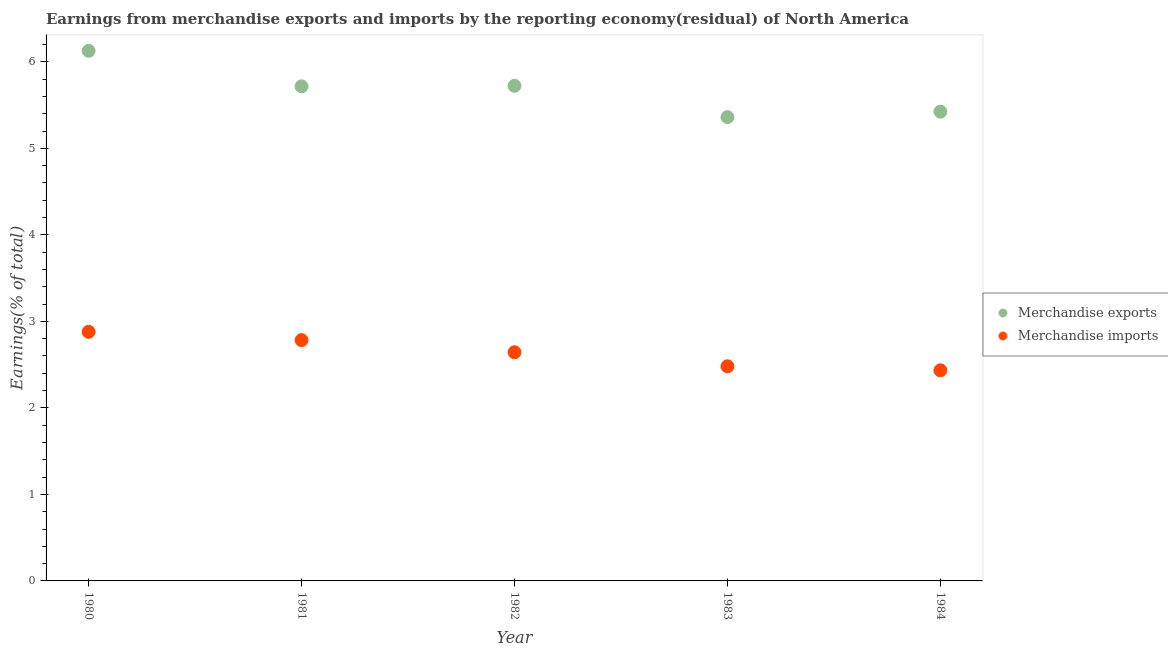Is the number of dotlines equal to the number of legend labels?
Your answer should be compact. Yes. What is the earnings from merchandise exports in 1983?
Make the answer very short. 5.36. Across all years, what is the maximum earnings from merchandise imports?
Provide a succinct answer. 2.88. Across all years, what is the minimum earnings from merchandise imports?
Offer a very short reply. 2.43. What is the total earnings from merchandise exports in the graph?
Make the answer very short. 28.35. What is the difference between the earnings from merchandise exports in 1980 and that in 1983?
Provide a succinct answer. 0.77. What is the difference between the earnings from merchandise exports in 1981 and the earnings from merchandise imports in 1980?
Make the answer very short. 2.84. What is the average earnings from merchandise imports per year?
Your answer should be very brief. 2.64. In the year 1984, what is the difference between the earnings from merchandise exports and earnings from merchandise imports?
Your answer should be very brief. 2.99. In how many years, is the earnings from merchandise imports greater than 2 %?
Offer a very short reply. 5. What is the ratio of the earnings from merchandise imports in 1981 to that in 1982?
Offer a very short reply. 1.05. Is the earnings from merchandise exports in 1981 less than that in 1983?
Keep it short and to the point. No. Is the difference between the earnings from merchandise imports in 1980 and 1981 greater than the difference between the earnings from merchandise exports in 1980 and 1981?
Keep it short and to the point. No. What is the difference between the highest and the second highest earnings from merchandise imports?
Ensure brevity in your answer.  0.1. What is the difference between the highest and the lowest earnings from merchandise exports?
Keep it short and to the point. 0.77. In how many years, is the earnings from merchandise imports greater than the average earnings from merchandise imports taken over all years?
Make the answer very short. 2. Is the sum of the earnings from merchandise imports in 1981 and 1983 greater than the maximum earnings from merchandise exports across all years?
Keep it short and to the point. No. Does the earnings from merchandise exports monotonically increase over the years?
Ensure brevity in your answer.  No. Is the earnings from merchandise imports strictly greater than the earnings from merchandise exports over the years?
Your answer should be compact. No. Is the earnings from merchandise imports strictly less than the earnings from merchandise exports over the years?
Provide a short and direct response. Yes. How many dotlines are there?
Your answer should be very brief. 2. How many years are there in the graph?
Your answer should be compact. 5. What is the difference between two consecutive major ticks on the Y-axis?
Your response must be concise. 1. Does the graph contain any zero values?
Keep it short and to the point. No. Where does the legend appear in the graph?
Make the answer very short. Center right. How many legend labels are there?
Offer a terse response. 2. What is the title of the graph?
Provide a short and direct response. Earnings from merchandise exports and imports by the reporting economy(residual) of North America. Does "Broad money growth" appear as one of the legend labels in the graph?
Keep it short and to the point. No. What is the label or title of the Y-axis?
Give a very brief answer. Earnings(% of total). What is the Earnings(% of total) of Merchandise exports in 1980?
Your answer should be compact. 6.13. What is the Earnings(% of total) of Merchandise imports in 1980?
Your answer should be very brief. 2.88. What is the Earnings(% of total) in Merchandise exports in 1981?
Keep it short and to the point. 5.72. What is the Earnings(% of total) in Merchandise imports in 1981?
Give a very brief answer. 2.78. What is the Earnings(% of total) of Merchandise exports in 1982?
Your answer should be very brief. 5.72. What is the Earnings(% of total) in Merchandise imports in 1982?
Offer a terse response. 2.64. What is the Earnings(% of total) of Merchandise exports in 1983?
Your answer should be very brief. 5.36. What is the Earnings(% of total) in Merchandise imports in 1983?
Offer a terse response. 2.48. What is the Earnings(% of total) in Merchandise exports in 1984?
Make the answer very short. 5.42. What is the Earnings(% of total) in Merchandise imports in 1984?
Ensure brevity in your answer.  2.43. Across all years, what is the maximum Earnings(% of total) of Merchandise exports?
Provide a short and direct response. 6.13. Across all years, what is the maximum Earnings(% of total) of Merchandise imports?
Provide a short and direct response. 2.88. Across all years, what is the minimum Earnings(% of total) of Merchandise exports?
Provide a succinct answer. 5.36. Across all years, what is the minimum Earnings(% of total) in Merchandise imports?
Keep it short and to the point. 2.43. What is the total Earnings(% of total) in Merchandise exports in the graph?
Your response must be concise. 28.35. What is the total Earnings(% of total) in Merchandise imports in the graph?
Make the answer very short. 13.22. What is the difference between the Earnings(% of total) in Merchandise exports in 1980 and that in 1981?
Provide a short and direct response. 0.41. What is the difference between the Earnings(% of total) of Merchandise imports in 1980 and that in 1981?
Give a very brief answer. 0.1. What is the difference between the Earnings(% of total) in Merchandise exports in 1980 and that in 1982?
Provide a succinct answer. 0.4. What is the difference between the Earnings(% of total) of Merchandise imports in 1980 and that in 1982?
Provide a short and direct response. 0.24. What is the difference between the Earnings(% of total) of Merchandise exports in 1980 and that in 1983?
Keep it short and to the point. 0.77. What is the difference between the Earnings(% of total) of Merchandise imports in 1980 and that in 1983?
Keep it short and to the point. 0.4. What is the difference between the Earnings(% of total) of Merchandise exports in 1980 and that in 1984?
Provide a succinct answer. 0.7. What is the difference between the Earnings(% of total) of Merchandise imports in 1980 and that in 1984?
Offer a terse response. 0.44. What is the difference between the Earnings(% of total) in Merchandise exports in 1981 and that in 1982?
Your response must be concise. -0.01. What is the difference between the Earnings(% of total) in Merchandise imports in 1981 and that in 1982?
Make the answer very short. 0.14. What is the difference between the Earnings(% of total) in Merchandise exports in 1981 and that in 1983?
Keep it short and to the point. 0.36. What is the difference between the Earnings(% of total) of Merchandise imports in 1981 and that in 1983?
Give a very brief answer. 0.3. What is the difference between the Earnings(% of total) of Merchandise exports in 1981 and that in 1984?
Your response must be concise. 0.29. What is the difference between the Earnings(% of total) of Merchandise imports in 1981 and that in 1984?
Make the answer very short. 0.35. What is the difference between the Earnings(% of total) in Merchandise exports in 1982 and that in 1983?
Offer a terse response. 0.36. What is the difference between the Earnings(% of total) in Merchandise imports in 1982 and that in 1983?
Provide a succinct answer. 0.16. What is the difference between the Earnings(% of total) of Merchandise exports in 1982 and that in 1984?
Your answer should be compact. 0.3. What is the difference between the Earnings(% of total) of Merchandise imports in 1982 and that in 1984?
Provide a short and direct response. 0.21. What is the difference between the Earnings(% of total) in Merchandise exports in 1983 and that in 1984?
Keep it short and to the point. -0.06. What is the difference between the Earnings(% of total) in Merchandise imports in 1983 and that in 1984?
Give a very brief answer. 0.05. What is the difference between the Earnings(% of total) in Merchandise exports in 1980 and the Earnings(% of total) in Merchandise imports in 1981?
Provide a short and direct response. 3.34. What is the difference between the Earnings(% of total) in Merchandise exports in 1980 and the Earnings(% of total) in Merchandise imports in 1982?
Provide a succinct answer. 3.48. What is the difference between the Earnings(% of total) of Merchandise exports in 1980 and the Earnings(% of total) of Merchandise imports in 1983?
Provide a short and direct response. 3.65. What is the difference between the Earnings(% of total) in Merchandise exports in 1980 and the Earnings(% of total) in Merchandise imports in 1984?
Your answer should be compact. 3.69. What is the difference between the Earnings(% of total) in Merchandise exports in 1981 and the Earnings(% of total) in Merchandise imports in 1982?
Offer a terse response. 3.07. What is the difference between the Earnings(% of total) of Merchandise exports in 1981 and the Earnings(% of total) of Merchandise imports in 1983?
Your response must be concise. 3.24. What is the difference between the Earnings(% of total) of Merchandise exports in 1981 and the Earnings(% of total) of Merchandise imports in 1984?
Provide a succinct answer. 3.28. What is the difference between the Earnings(% of total) of Merchandise exports in 1982 and the Earnings(% of total) of Merchandise imports in 1983?
Your answer should be very brief. 3.24. What is the difference between the Earnings(% of total) in Merchandise exports in 1982 and the Earnings(% of total) in Merchandise imports in 1984?
Your response must be concise. 3.29. What is the difference between the Earnings(% of total) of Merchandise exports in 1983 and the Earnings(% of total) of Merchandise imports in 1984?
Keep it short and to the point. 2.93. What is the average Earnings(% of total) in Merchandise exports per year?
Offer a terse response. 5.67. What is the average Earnings(% of total) of Merchandise imports per year?
Offer a very short reply. 2.64. In the year 1980, what is the difference between the Earnings(% of total) of Merchandise exports and Earnings(% of total) of Merchandise imports?
Your response must be concise. 3.25. In the year 1981, what is the difference between the Earnings(% of total) of Merchandise exports and Earnings(% of total) of Merchandise imports?
Your answer should be compact. 2.93. In the year 1982, what is the difference between the Earnings(% of total) in Merchandise exports and Earnings(% of total) in Merchandise imports?
Give a very brief answer. 3.08. In the year 1983, what is the difference between the Earnings(% of total) in Merchandise exports and Earnings(% of total) in Merchandise imports?
Make the answer very short. 2.88. In the year 1984, what is the difference between the Earnings(% of total) of Merchandise exports and Earnings(% of total) of Merchandise imports?
Your answer should be very brief. 2.99. What is the ratio of the Earnings(% of total) in Merchandise exports in 1980 to that in 1981?
Offer a very short reply. 1.07. What is the ratio of the Earnings(% of total) in Merchandise imports in 1980 to that in 1981?
Offer a very short reply. 1.03. What is the ratio of the Earnings(% of total) in Merchandise exports in 1980 to that in 1982?
Offer a terse response. 1.07. What is the ratio of the Earnings(% of total) in Merchandise imports in 1980 to that in 1982?
Offer a terse response. 1.09. What is the ratio of the Earnings(% of total) in Merchandise exports in 1980 to that in 1983?
Keep it short and to the point. 1.14. What is the ratio of the Earnings(% of total) of Merchandise imports in 1980 to that in 1983?
Your answer should be compact. 1.16. What is the ratio of the Earnings(% of total) in Merchandise exports in 1980 to that in 1984?
Provide a succinct answer. 1.13. What is the ratio of the Earnings(% of total) in Merchandise imports in 1980 to that in 1984?
Your answer should be compact. 1.18. What is the ratio of the Earnings(% of total) in Merchandise exports in 1981 to that in 1982?
Provide a short and direct response. 1. What is the ratio of the Earnings(% of total) of Merchandise imports in 1981 to that in 1982?
Offer a terse response. 1.05. What is the ratio of the Earnings(% of total) of Merchandise exports in 1981 to that in 1983?
Make the answer very short. 1.07. What is the ratio of the Earnings(% of total) of Merchandise imports in 1981 to that in 1983?
Your response must be concise. 1.12. What is the ratio of the Earnings(% of total) of Merchandise exports in 1981 to that in 1984?
Make the answer very short. 1.05. What is the ratio of the Earnings(% of total) in Merchandise imports in 1981 to that in 1984?
Ensure brevity in your answer.  1.14. What is the ratio of the Earnings(% of total) in Merchandise exports in 1982 to that in 1983?
Provide a short and direct response. 1.07. What is the ratio of the Earnings(% of total) of Merchandise imports in 1982 to that in 1983?
Offer a very short reply. 1.07. What is the ratio of the Earnings(% of total) of Merchandise exports in 1982 to that in 1984?
Provide a short and direct response. 1.06. What is the ratio of the Earnings(% of total) of Merchandise imports in 1982 to that in 1984?
Give a very brief answer. 1.09. What is the ratio of the Earnings(% of total) in Merchandise exports in 1983 to that in 1984?
Offer a very short reply. 0.99. What is the ratio of the Earnings(% of total) in Merchandise imports in 1983 to that in 1984?
Provide a succinct answer. 1.02. What is the difference between the highest and the second highest Earnings(% of total) in Merchandise exports?
Give a very brief answer. 0.4. What is the difference between the highest and the second highest Earnings(% of total) in Merchandise imports?
Ensure brevity in your answer.  0.1. What is the difference between the highest and the lowest Earnings(% of total) in Merchandise exports?
Offer a terse response. 0.77. What is the difference between the highest and the lowest Earnings(% of total) of Merchandise imports?
Give a very brief answer. 0.44. 